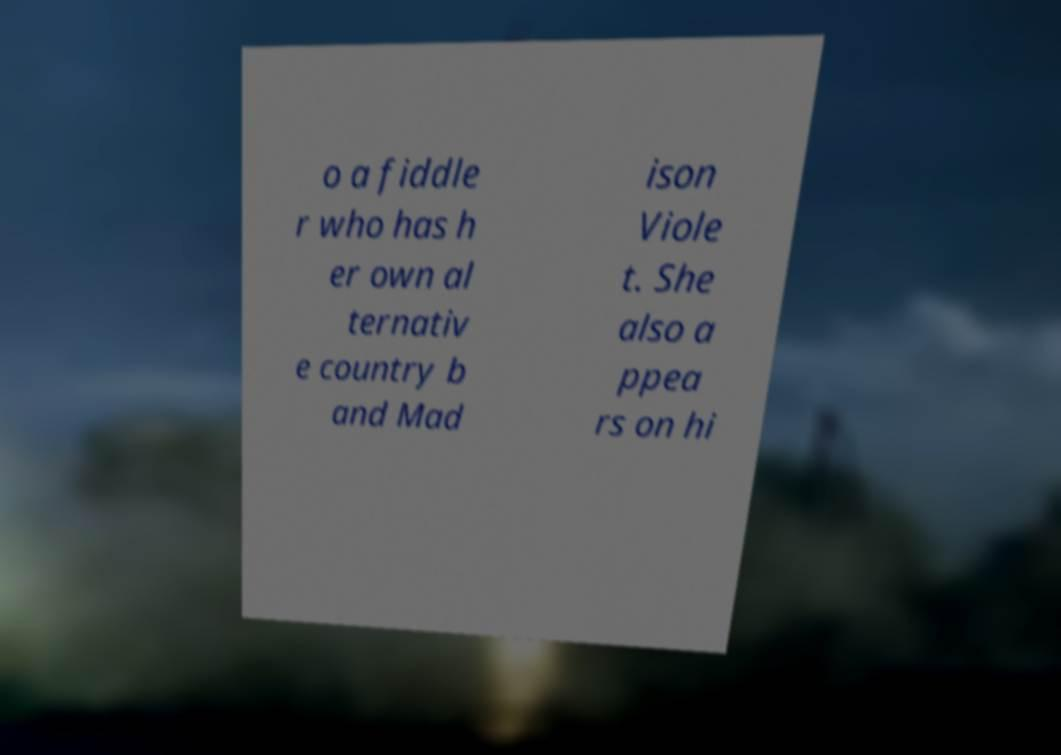Can you accurately transcribe the text from the provided image for me? o a fiddle r who has h er own al ternativ e country b and Mad ison Viole t. She also a ppea rs on hi 